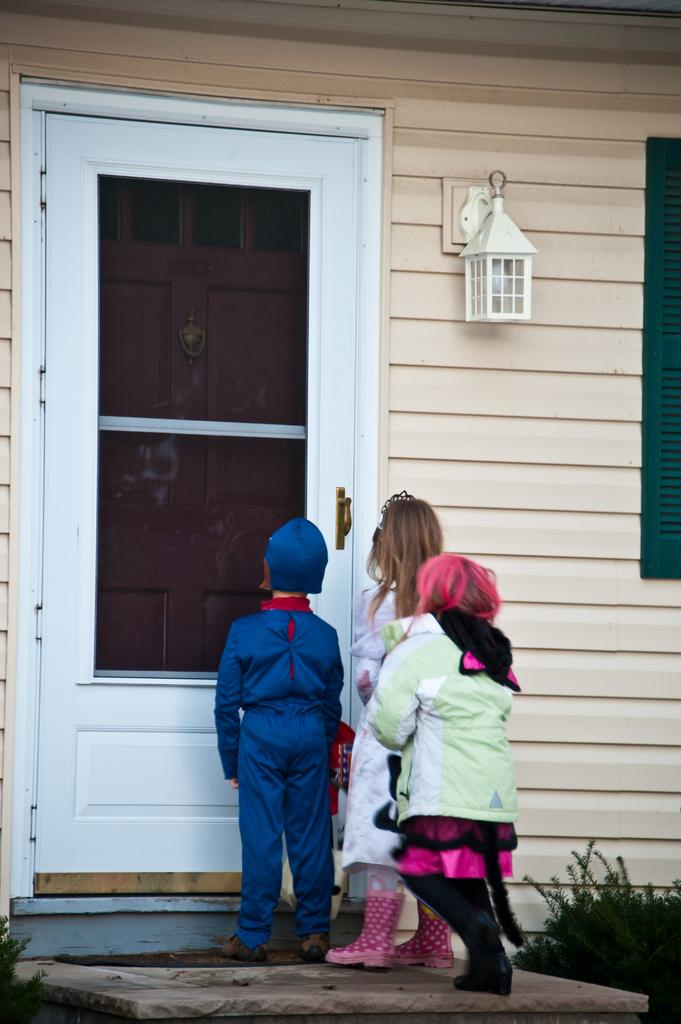How many kids are in the image? There are three kids in the image. Where are the kids located in relation to the house? The kids are standing near the door of a house. What else can be seen in the image besides the kids and the house? There are plants in the image. What holiday is being celebrated in the image? There is no indication of a holiday being celebrated in the image. How does the door of the house pull the kids towards it? The door of the house does not pull the kids towards it; they are standing near the door of their own volition. 